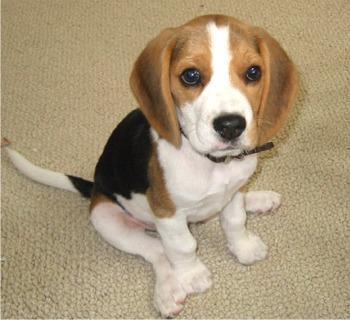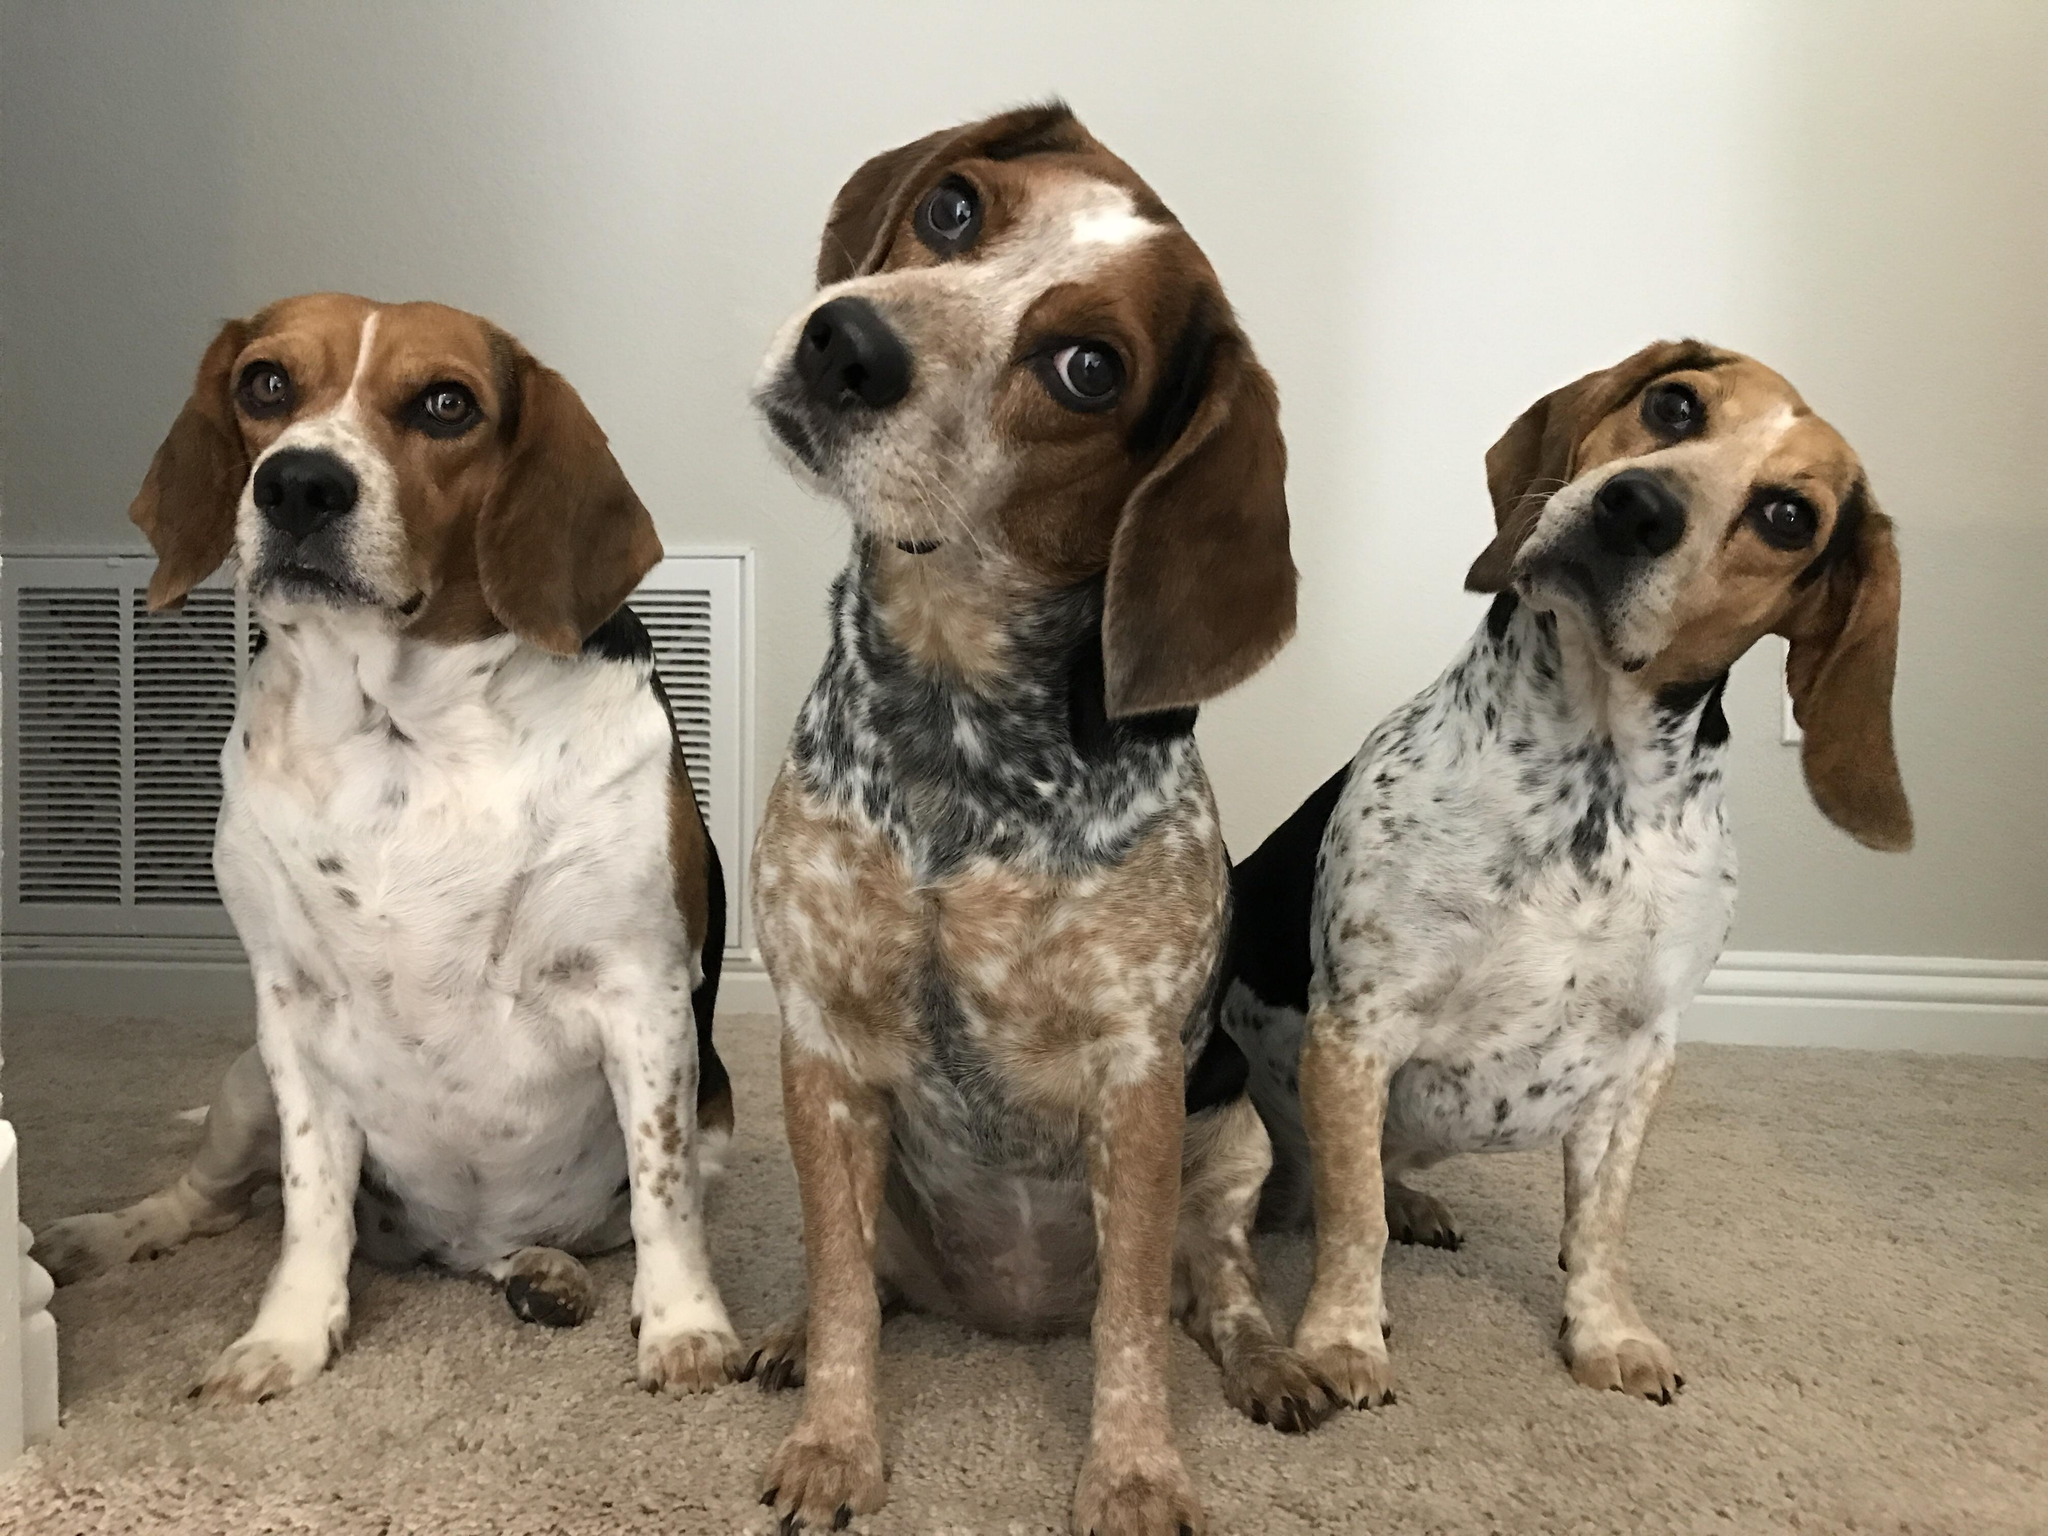The first image is the image on the left, the second image is the image on the right. Given the left and right images, does the statement "In one image there is a single puppy sitting on the ground." hold true? Answer yes or no. Yes. The first image is the image on the left, the second image is the image on the right. Given the left and right images, does the statement "There is one puppy sitting by itself in one of the images." hold true? Answer yes or no. Yes. 